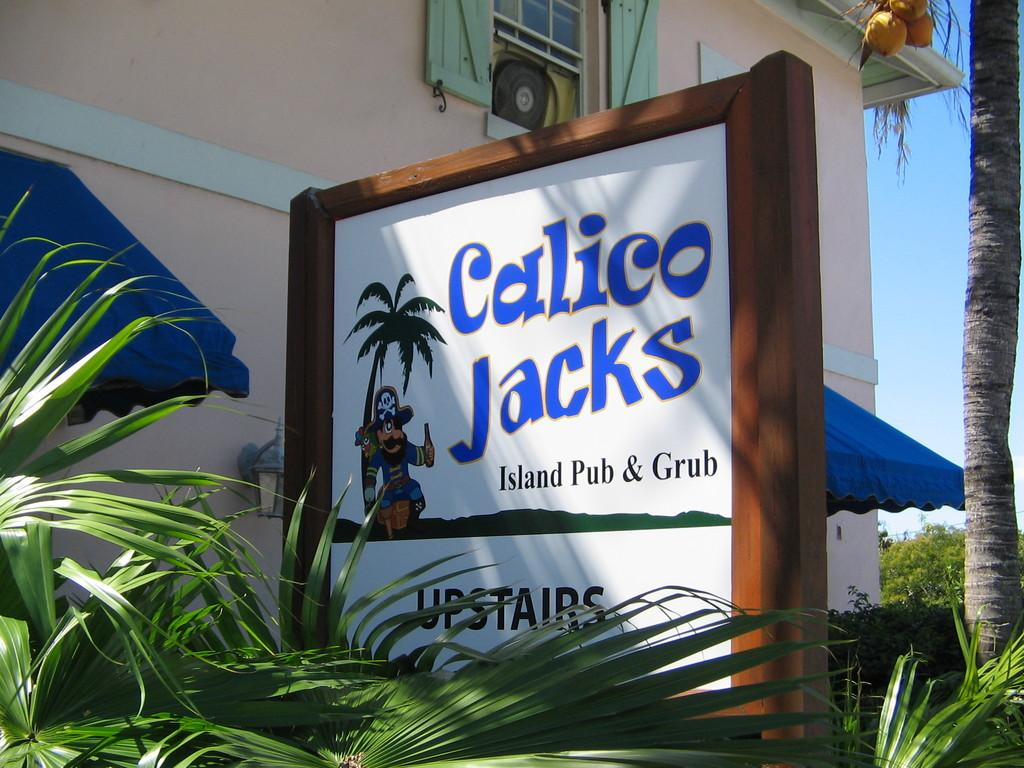What type of structure is visible in the image? There is a building in the image. What type of natural vegetation is present in the image? There are trees in the image. What is placed on plants in the image? There is a board placed on plants in the image. What type of pollution can be seen in the image? There is no pollution visible in the image. What part of the brain can be seen in the image? There is no part of the brain present in the image. 